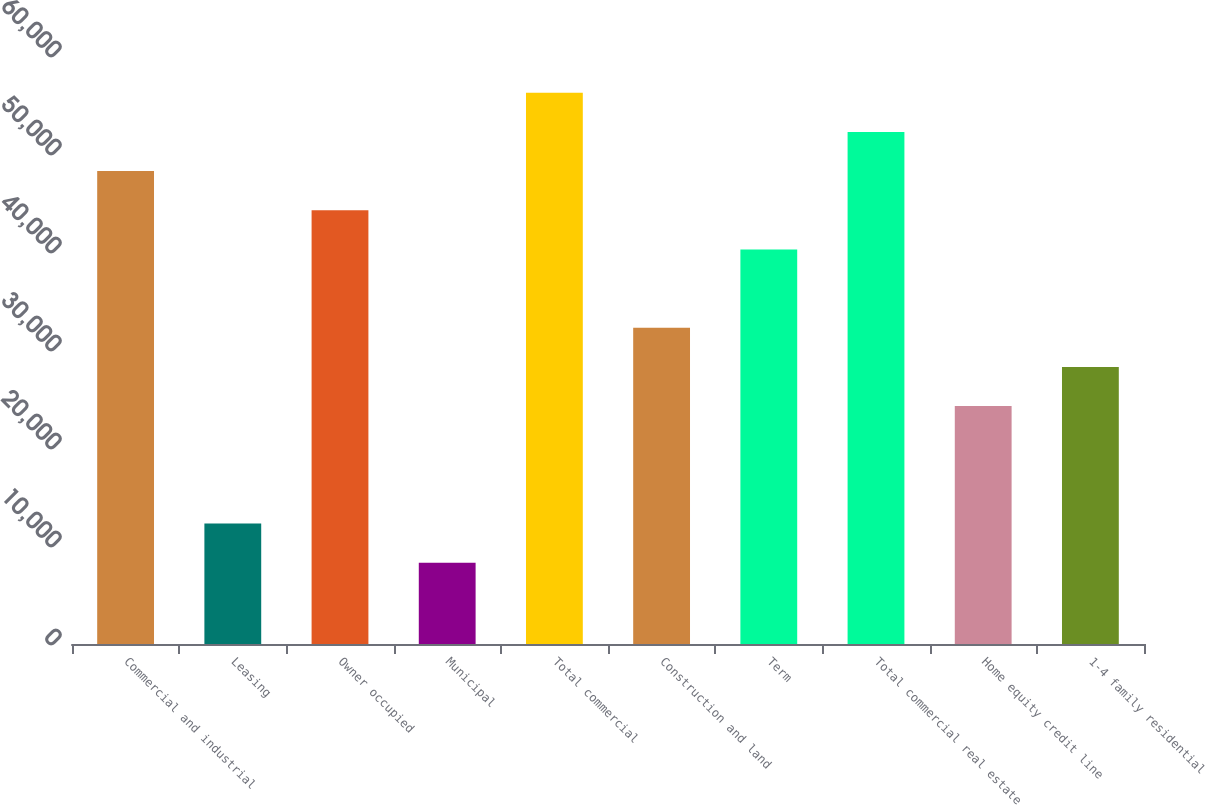<chart> <loc_0><loc_0><loc_500><loc_500><bar_chart><fcel>Commercial and industrial<fcel>Leasing<fcel>Owner occupied<fcel>Municipal<fcel>Total commercial<fcel>Construction and land<fcel>Term<fcel>Total commercial real estate<fcel>Home equity credit line<fcel>1-4 family residential<nl><fcel>48253.2<fcel>12283.8<fcel>44256.6<fcel>8287.2<fcel>56246.4<fcel>32266.8<fcel>40260<fcel>52249.8<fcel>24273.6<fcel>28270.2<nl></chart> 